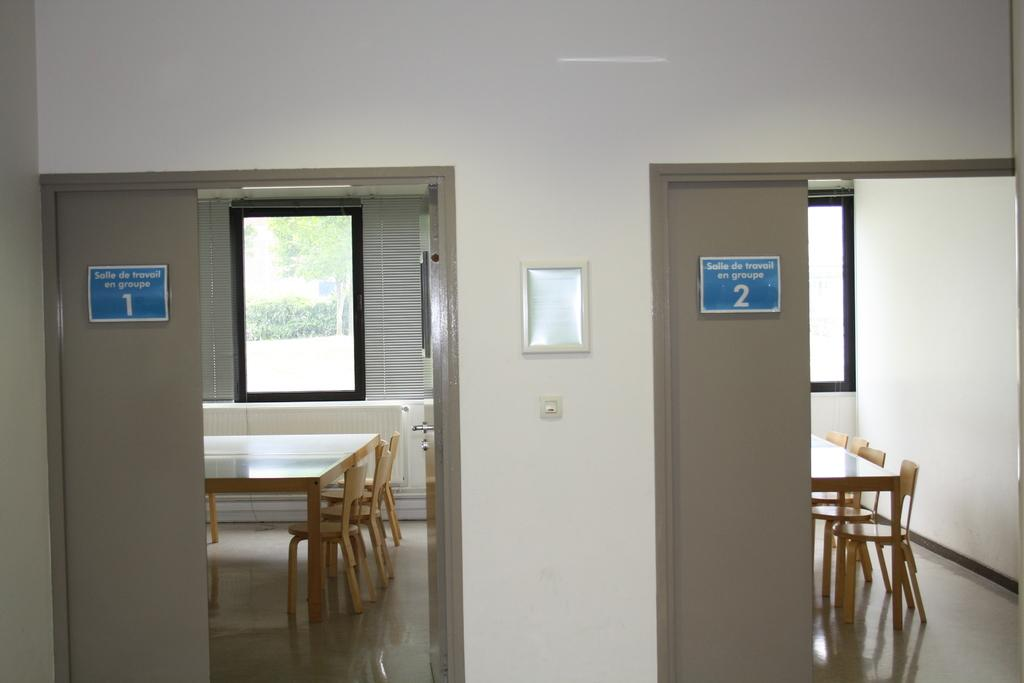What type of openings can be seen in the image? There are doors in the image. What is written on the doors? There are boards with writing on the doors. What type of furniture is present in the image? There are tables and chairs in the image. What can be seen in the background of the image? There are windows in the background of the image. What type of window treatment is present in the image? There is a curtain in the image. Can you hear the thunder in the image? There is no mention of thunder or any sound in the image, so it cannot be heard. Is there a rabbit visible in the image? There is no rabbit present in the image. 